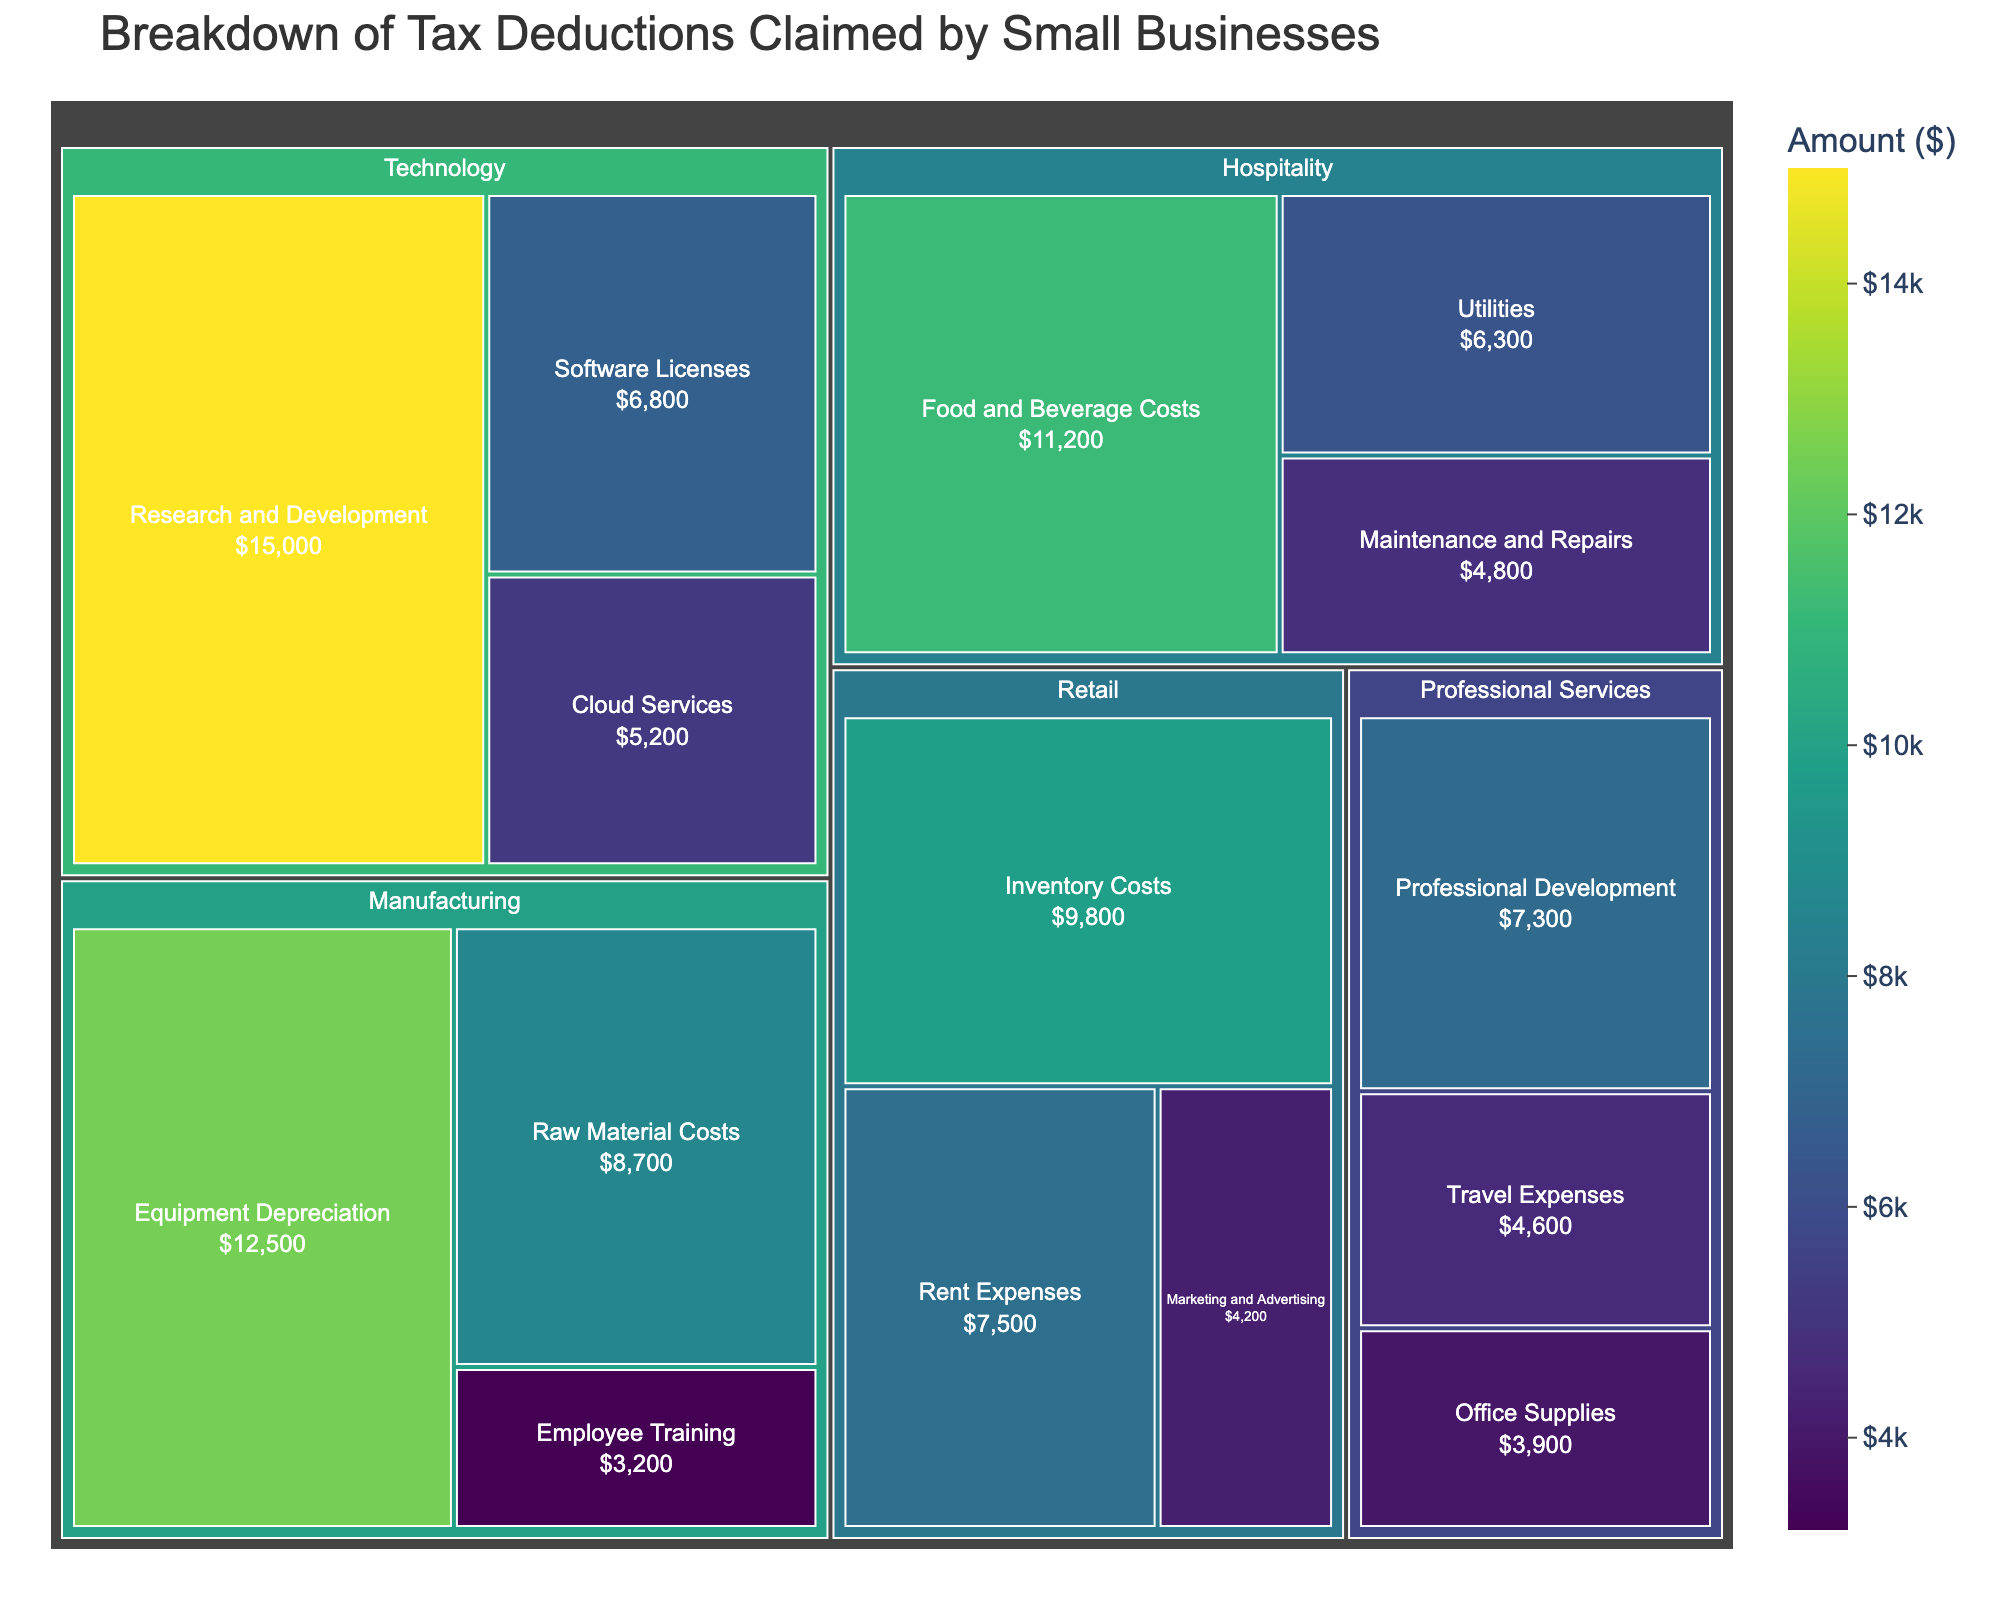What is the total amount claimed for Research and Development in the Technology sector? In the treemap, locate the Technology sector and find the category labeled Research and Development. The amount claimed is displayed in this section.
Answer: $15,000 Which sector has the largest single tax deduction claim? By examining the treemap, the sector with the largest segment should be identified. The largest amount seen is in the Technology sector for Research and Development.
Answer: Technology What is the combined total amount for Equipment Depreciation and Raw Material Costs in the Manufacturing sector? Locate both Equipment Depreciation and Raw Material Costs within the Manufacturing sector on the treemap. Add their amounts: $12,500 + $8,700.
Answer: $21,200 Between Inventory Costs and Rent Expenses, which category in the Retail sector has a higher claim amount? Look at the categories under the Retail sector in the treemap. Compare the amounts for Inventory Costs ($9,800) and Rent Expenses ($7,500).
Answer: Inventory Costs Across all sectors, which category has the smallest tax deduction claim? Identify the category with the smallest values in all sectors. The smallest value in the treemap is for Employee Training in the Manufacturing sector.
Answer: Employee Training What is the total amount claimed by the Professional Services sector? Summarize all the amounts within the Professional Services sector: Professional Development ($7,300), Office Supplies ($3,900), and Travel Expenses ($4,600).
Answer: $15,800 How does the total claim for Cloud Services in the Technology sector compare to Utilities in the Hospitality sector? Find both Cloud Services in the Technology sector and Utilities in the Hospitality sector. Compare $5,200 (Cloud Services) to $6,300 (Utilities).
Answer: Utilities is higher Which sector has the highest collective amount for training and development-related expenses? Look for categories related to training and development across sectors. Combine amounts for Employee Training (Manufacturing), Professional Development (Professional Services), and Research and Development (Technology). Research and Development has the highest single claim of $15,000.
Answer: Technology How many distinct categories are there in the Retail sector? Count the individual labeled sections under the Retail sector in the treemap.
Answer: 3 What is the difference between the amount claimed for Food and Beverage Costs and Maintenance and Repairs in the Hospitality sector? Find both Food and Beverage Costs and Maintenance and Repairs within the Hospitality sector. Calculate the difference: $11,200 - $4,800.
Answer: $6,400 